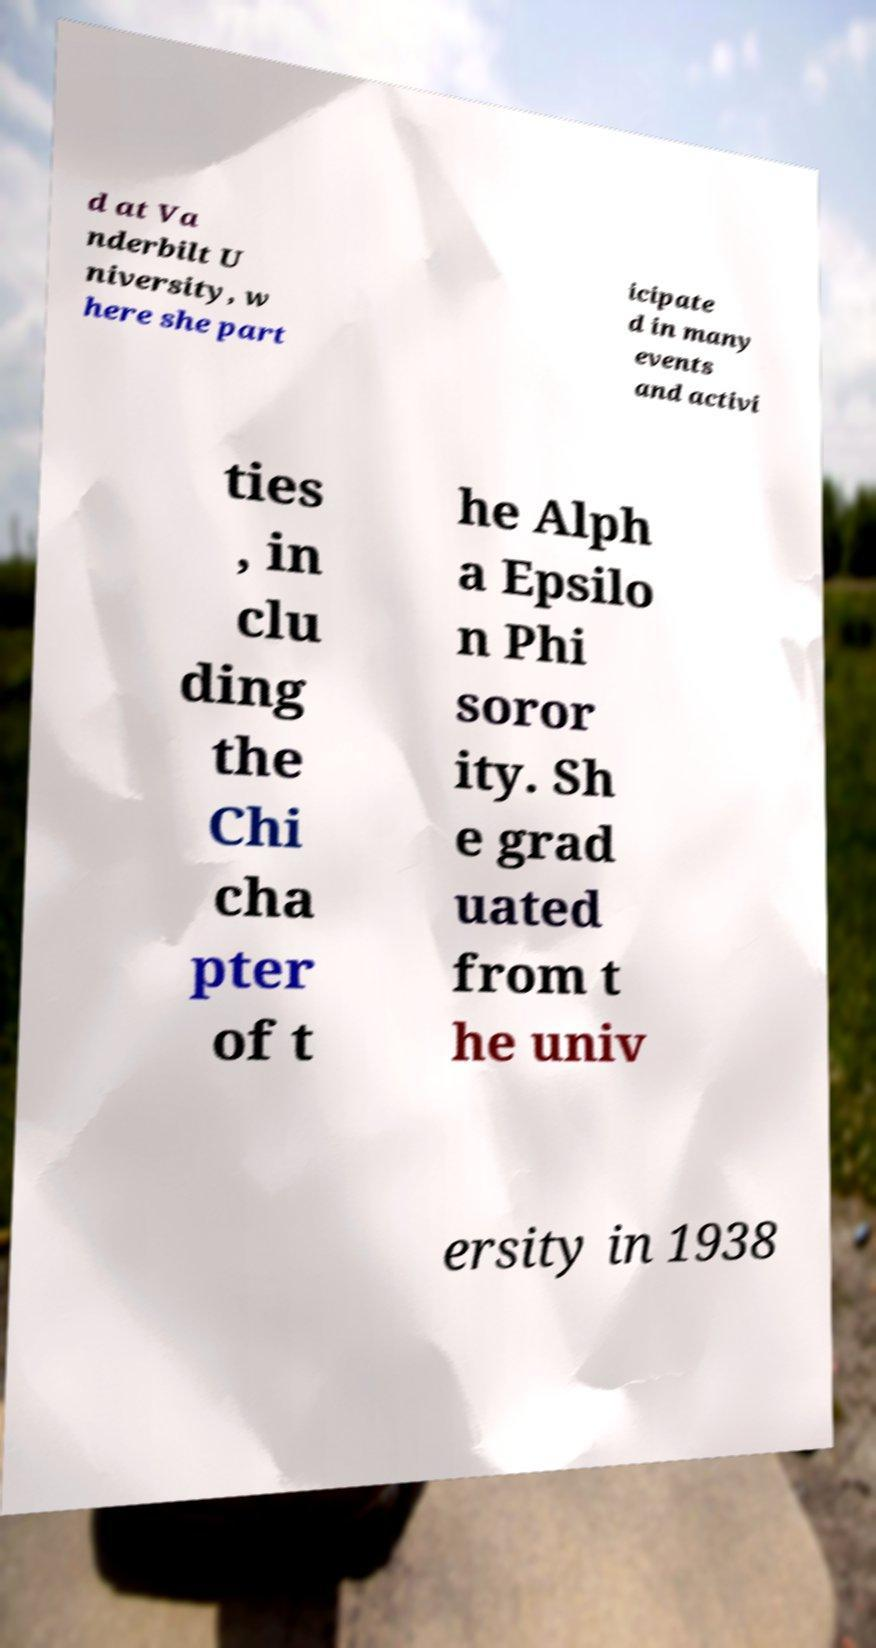For documentation purposes, I need the text within this image transcribed. Could you provide that? d at Va nderbilt U niversity, w here she part icipate d in many events and activi ties , in clu ding the Chi cha pter of t he Alph a Epsilo n Phi soror ity. Sh e grad uated from t he univ ersity in 1938 